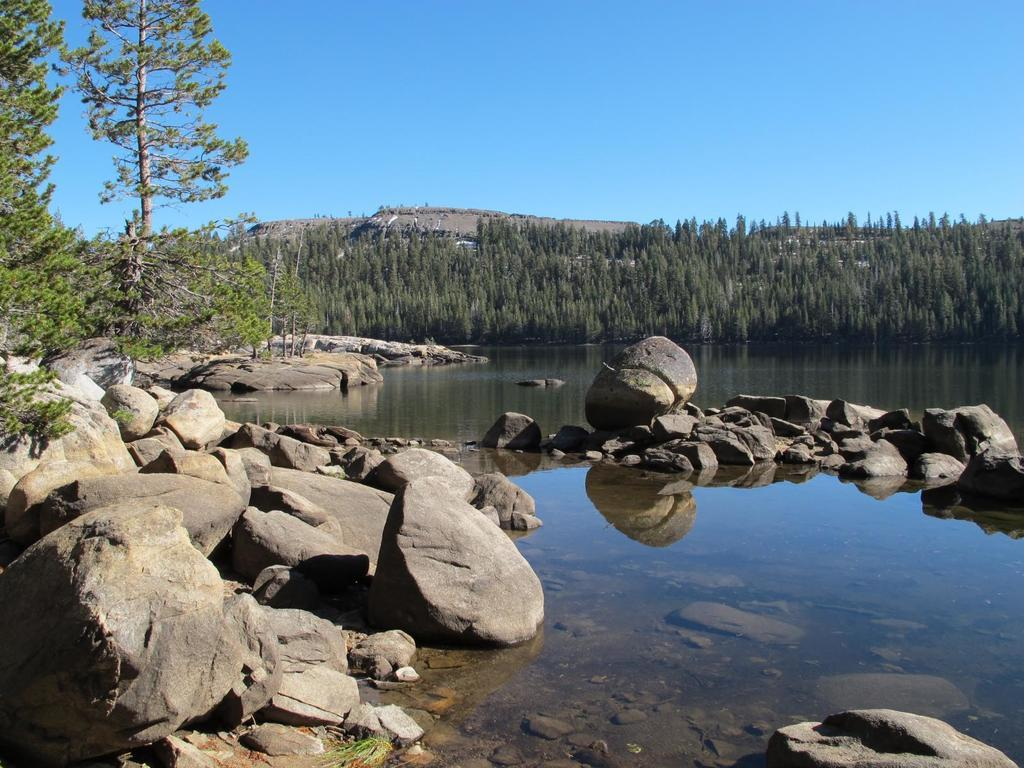What is located in the front of the image? There are stones in the front of the image. What is in the center of the image? There is water in the center of the image. What can be seen in the background of the image? There are trees in the background of the image. How many babies are being supported by the trees in the image? There are no babies present in the image, and the trees are not supporting any objects or individuals. 